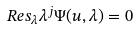Convert formula to latex. <formula><loc_0><loc_0><loc_500><loc_500>R e s _ { \lambda } \lambda ^ { j } \Psi ( { u } , \lambda ) = 0</formula> 